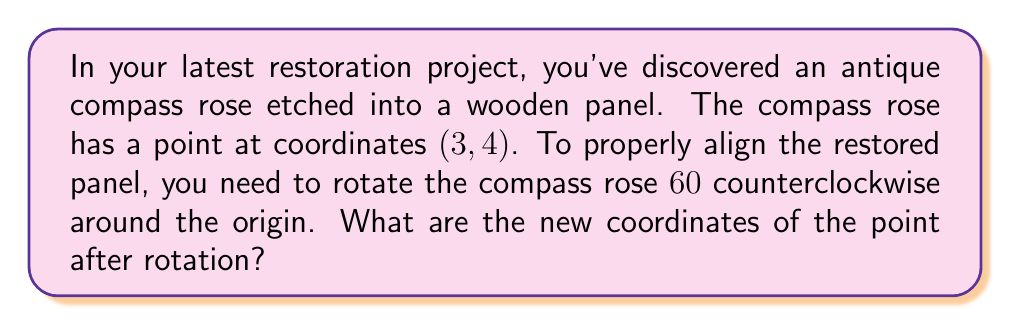Can you answer this question? To find the new coordinates of a point after rotation around the origin, we use the rotation matrix. For a counterclockwise rotation by an angle $\theta$, the matrix is:

$$
\begin{bmatrix}
\cos\theta & -\sin\theta \\
\sin\theta & \cos\theta
\end{bmatrix}
$$

For a $60°$ rotation, $\theta = 60°$ or $\frac{\pi}{3}$ radians. Let's follow these steps:

1) First, recall the values of $\cos 60°$ and $\sin 60°$:
   $\cos 60° = \frac{1}{2}$
   $\sin 60° = \frac{\sqrt{3}}{2}$

2) Now, let's set up our rotation matrix:
   $$
   \begin{bmatrix}
   \frac{1}{2} & -\frac{\sqrt{3}}{2} \\
   \frac{\sqrt{3}}{2} & \frac{1}{2}
   \end{bmatrix}
   $$

3) Multiply this matrix by the original point coordinates:
   $$
   \begin{bmatrix}
   \frac{1}{2} & -\frac{\sqrt{3}}{2} \\
   \frac{\sqrt{3}}{2} & \frac{1}{2}
   \end{bmatrix}
   \begin{bmatrix}
   3 \\
   4
   \end{bmatrix}
   $$

4) Perform the matrix multiplication:
   $$
   \begin{bmatrix}
   (\frac{1}{2})(3) + (-\frac{\sqrt{3}}{2})(4) \\
   (\frac{\sqrt{3}}{2})(3) + (\frac{1}{2})(4)
   \end{bmatrix}
   $$

5) Simplify:
   $$
   \begin{bmatrix}
   \frac{3}{2} - 2\sqrt{3} \\
   \frac{3\sqrt{3}}{2} + 2
   \end{bmatrix}
   $$

6) The new x-coordinate is $\frac{3}{2} - 2\sqrt{3}$ and the new y-coordinate is $\frac{3\sqrt{3}}{2} + 2$.
Answer: The new coordinates of the point after rotation are $(\frac{3}{2} - 2\sqrt{3}, \frac{3\sqrt{3}}{2} + 2)$. 